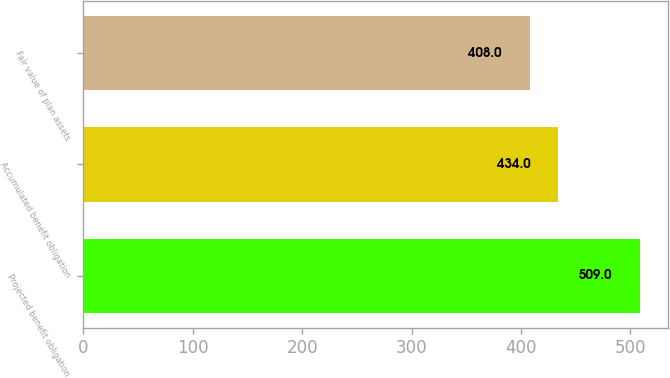Convert chart to OTSL. <chart><loc_0><loc_0><loc_500><loc_500><bar_chart><fcel>Projected benefit obligation<fcel>Accumulated benefit obligation<fcel>Fair value of plan assets<nl><fcel>509<fcel>434<fcel>408<nl></chart> 